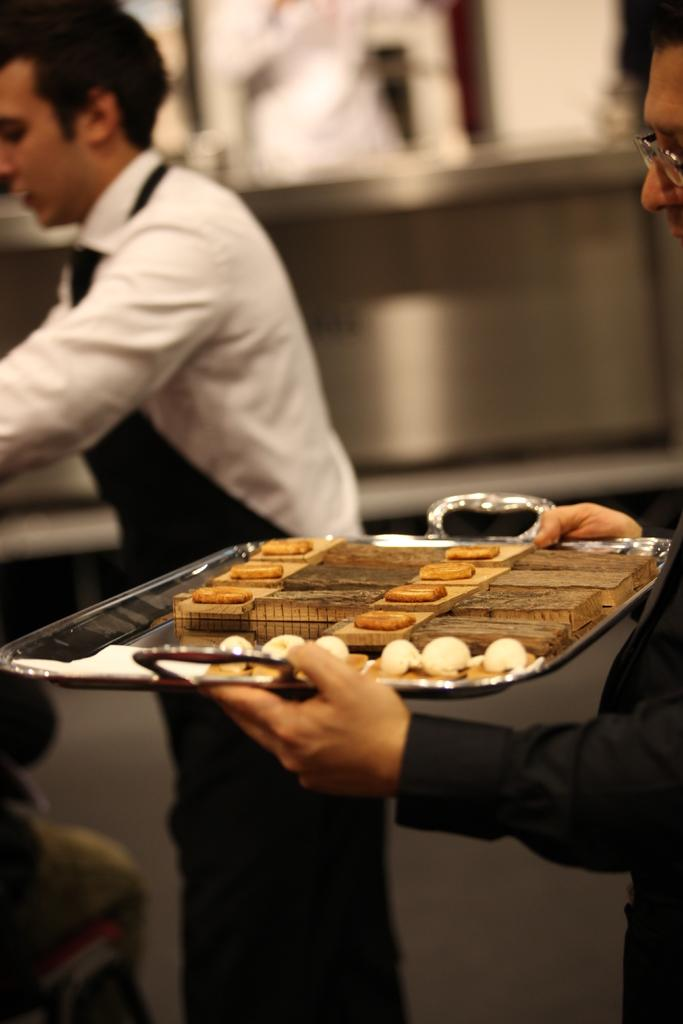What is the person on the right side of the image holding? The person is holding a tray on the right side of the image. What is on the tray that the person is holding? There are cookies on the tray. What can be seen on the left side of the image? There is another person on the left side of the image. Can you describe the background of the image? The background of the image is blurry. What type of design can be seen on the bee in the image? There are no bees present in the image, so it is not possible to answer that question. How much milk is being poured by the person on the left side of the image? There is no milk or pouring action visible in the image. 